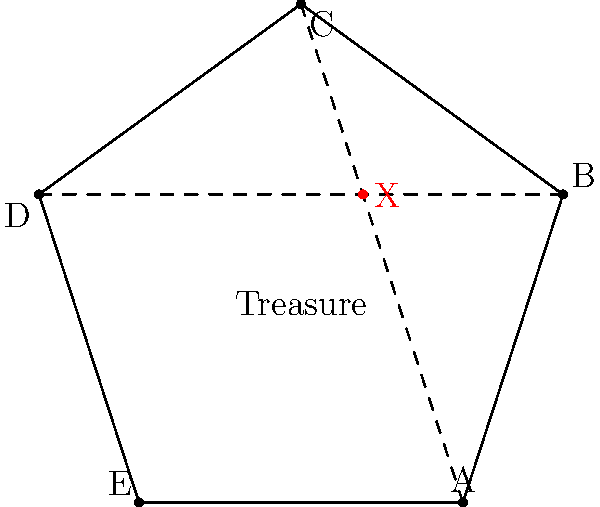In this ancient Viking treasure map, five landmarks (A, B, C, D, and E) form a pentagon. The treasure is hidden at the intersection of two secret paths connecting opposite landmarks. If the first path connects A to C, which two landmarks must be connected by the second path to locate the treasure at point X? To solve this puzzle, we need to follow these steps:

1. Identify the given information:
   - The map is in the shape of a pentagon with landmarks A, B, C, D, and E.
   - The treasure (X) is located at the intersection of two secret paths.
   - One path connects landmarks A and C.

2. Understand the concept of "opposite" landmarks in a pentagon:
   - In a pentagon, opposite landmarks are separated by two vertices.

3. Identify the opposite landmarks:
   - A is opposite to C and D
   - B is opposite to D and E
   - C is opposite to E and A
   - D is opposite to A and B
   - E is opposite to B and C

4. Determine the second path:
   - Since A and C are already connected, we need to find the pair of opposite landmarks that don't include A or C.
   - The only pair that satisfies this condition is B and D.

5. Conclude:
   - The second path must connect landmarks B and D to intersect with AC at point X, where the treasure is located.
Answer: B and D 